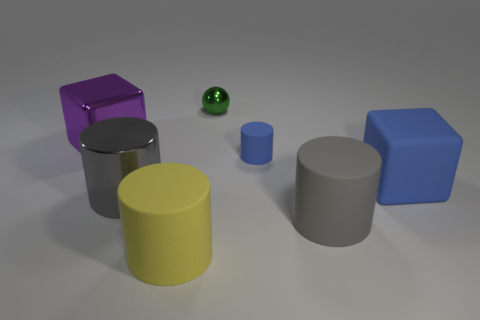The matte object that is the same color as the matte block is what size?
Your answer should be very brief. Small. The large object that is the same color as the small rubber object is what shape?
Offer a terse response. Cube. Do the gray cylinder that is in front of the big gray shiny thing and the yellow thing have the same material?
Your answer should be compact. Yes. There is a block behind the matte cube; what is its size?
Make the answer very short. Large. Are there any big things left of the shiny object that is in front of the big metal block?
Keep it short and to the point. Yes. Is the color of the big rubber cylinder on the right side of the tiny metal thing the same as the large cylinder to the left of the large yellow matte cylinder?
Provide a succinct answer. Yes. The big metallic cylinder has what color?
Provide a short and direct response. Gray. Is there any other thing that has the same color as the shiny sphere?
Your response must be concise. No. What color is the big matte object that is both to the right of the yellow cylinder and on the left side of the large blue rubber thing?
Your answer should be very brief. Gray. There is a cube right of the sphere; is its size the same as the green object?
Offer a very short reply. No. 